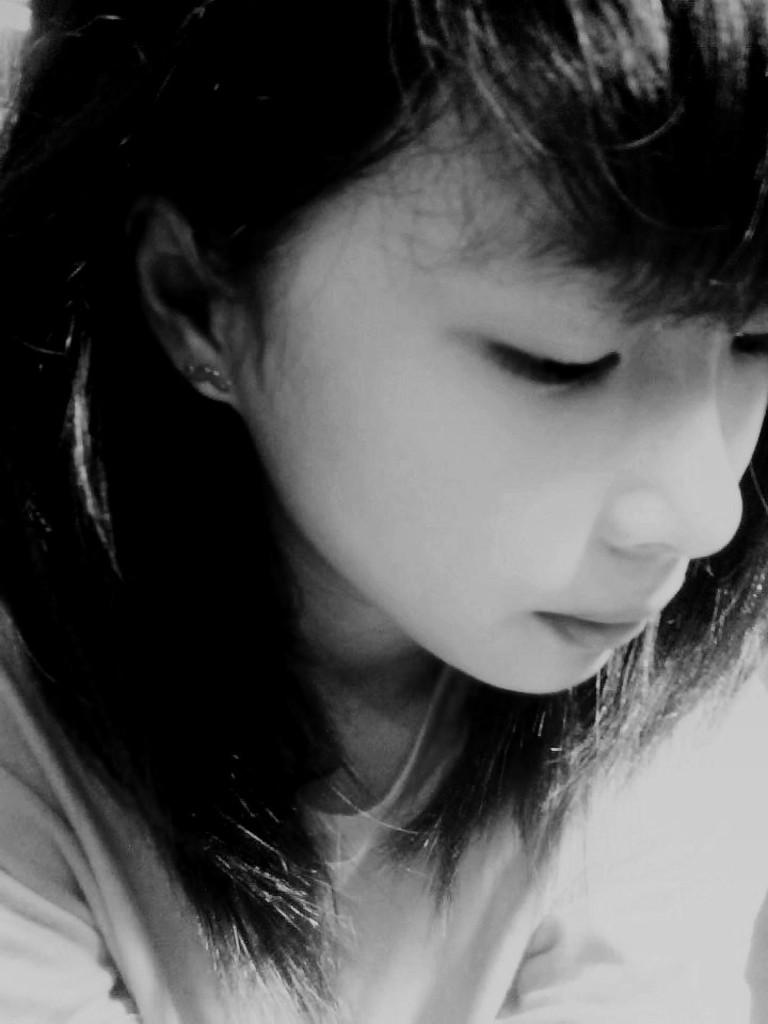What is present in the image? There is a person in the image. What is the person wearing? The person is wearing a dress. What is the color scheme of the image? The image is black and white. What color crayon is the person holding in the image? There is no crayon present in the image. Are the person's socks visible in the image? The provided facts do not mention socks, so we cannot determine if they are visible or not. 